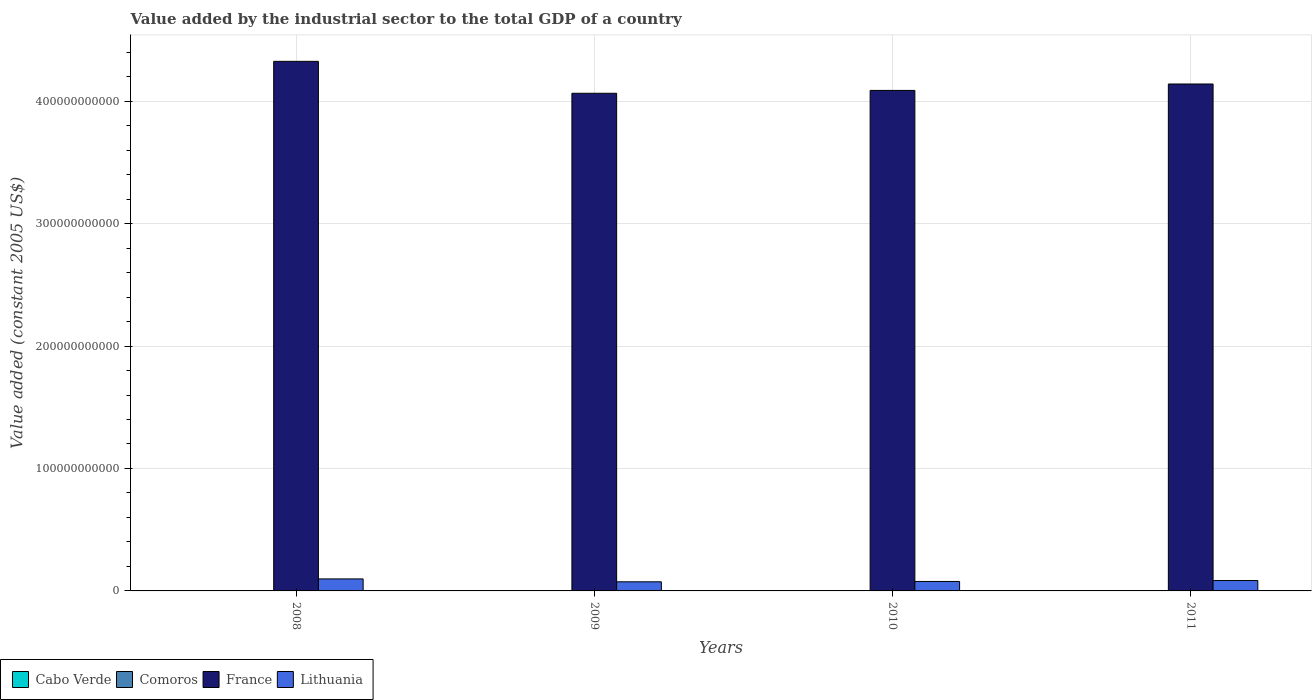How many different coloured bars are there?
Provide a succinct answer. 4. How many groups of bars are there?
Your answer should be compact. 4. How many bars are there on the 2nd tick from the right?
Make the answer very short. 4. In how many cases, is the number of bars for a given year not equal to the number of legend labels?
Give a very brief answer. 0. What is the value added by the industrial sector in Cabo Verde in 2009?
Offer a very short reply. 2.57e+08. Across all years, what is the maximum value added by the industrial sector in Lithuania?
Your answer should be compact. 9.80e+09. Across all years, what is the minimum value added by the industrial sector in Comoros?
Provide a short and direct response. 4.62e+07. In which year was the value added by the industrial sector in Comoros maximum?
Your response must be concise. 2011. What is the total value added by the industrial sector in Comoros in the graph?
Offer a terse response. 2.01e+08. What is the difference between the value added by the industrial sector in Comoros in 2008 and that in 2009?
Your response must be concise. -9.57e+05. What is the difference between the value added by the industrial sector in Cabo Verde in 2008 and the value added by the industrial sector in Lithuania in 2011?
Make the answer very short. -8.21e+09. What is the average value added by the industrial sector in Cabo Verde per year?
Give a very brief answer. 2.57e+08. In the year 2008, what is the difference between the value added by the industrial sector in Comoros and value added by the industrial sector in France?
Keep it short and to the point. -4.32e+11. In how many years, is the value added by the industrial sector in France greater than 260000000000 US$?
Keep it short and to the point. 4. What is the ratio of the value added by the industrial sector in Comoros in 2008 to that in 2010?
Offer a very short reply. 0.87. Is the value added by the industrial sector in France in 2008 less than that in 2011?
Give a very brief answer. No. Is the difference between the value added by the industrial sector in Comoros in 2008 and 2010 greater than the difference between the value added by the industrial sector in France in 2008 and 2010?
Make the answer very short. No. What is the difference between the highest and the second highest value added by the industrial sector in France?
Provide a succinct answer. 1.85e+1. What is the difference between the highest and the lowest value added by the industrial sector in France?
Ensure brevity in your answer.  2.61e+1. In how many years, is the value added by the industrial sector in Comoros greater than the average value added by the industrial sector in Comoros taken over all years?
Ensure brevity in your answer.  2. Is it the case that in every year, the sum of the value added by the industrial sector in Cabo Verde and value added by the industrial sector in Comoros is greater than the sum of value added by the industrial sector in France and value added by the industrial sector in Lithuania?
Make the answer very short. No. What does the 2nd bar from the left in 2009 represents?
Provide a short and direct response. Comoros. How many bars are there?
Your answer should be compact. 16. What is the difference between two consecutive major ticks on the Y-axis?
Your answer should be very brief. 1.00e+11. Are the values on the major ticks of Y-axis written in scientific E-notation?
Ensure brevity in your answer.  No. Does the graph contain grids?
Keep it short and to the point. Yes. Where does the legend appear in the graph?
Your response must be concise. Bottom left. How are the legend labels stacked?
Make the answer very short. Horizontal. What is the title of the graph?
Your answer should be compact. Value added by the industrial sector to the total GDP of a country. Does "Italy" appear as one of the legend labels in the graph?
Keep it short and to the point. No. What is the label or title of the X-axis?
Offer a very short reply. Years. What is the label or title of the Y-axis?
Your answer should be compact. Value added (constant 2005 US$). What is the Value added (constant 2005 US$) in Cabo Verde in 2008?
Ensure brevity in your answer.  2.71e+08. What is the Value added (constant 2005 US$) in Comoros in 2008?
Give a very brief answer. 4.62e+07. What is the Value added (constant 2005 US$) of France in 2008?
Make the answer very short. 4.33e+11. What is the Value added (constant 2005 US$) of Lithuania in 2008?
Provide a succinct answer. 9.80e+09. What is the Value added (constant 2005 US$) in Cabo Verde in 2009?
Your answer should be very brief. 2.57e+08. What is the Value added (constant 2005 US$) in Comoros in 2009?
Keep it short and to the point. 4.71e+07. What is the Value added (constant 2005 US$) in France in 2009?
Provide a succinct answer. 4.06e+11. What is the Value added (constant 2005 US$) in Lithuania in 2009?
Give a very brief answer. 7.44e+09. What is the Value added (constant 2005 US$) of Cabo Verde in 2010?
Give a very brief answer. 2.48e+08. What is the Value added (constant 2005 US$) of Comoros in 2010?
Provide a succinct answer. 5.31e+07. What is the Value added (constant 2005 US$) in France in 2010?
Provide a short and direct response. 4.09e+11. What is the Value added (constant 2005 US$) in Lithuania in 2010?
Your answer should be compact. 7.73e+09. What is the Value added (constant 2005 US$) in Cabo Verde in 2011?
Your answer should be very brief. 2.51e+08. What is the Value added (constant 2005 US$) of Comoros in 2011?
Give a very brief answer. 5.48e+07. What is the Value added (constant 2005 US$) of France in 2011?
Keep it short and to the point. 4.14e+11. What is the Value added (constant 2005 US$) of Lithuania in 2011?
Make the answer very short. 8.48e+09. Across all years, what is the maximum Value added (constant 2005 US$) in Cabo Verde?
Keep it short and to the point. 2.71e+08. Across all years, what is the maximum Value added (constant 2005 US$) of Comoros?
Give a very brief answer. 5.48e+07. Across all years, what is the maximum Value added (constant 2005 US$) of France?
Your answer should be compact. 4.33e+11. Across all years, what is the maximum Value added (constant 2005 US$) in Lithuania?
Offer a very short reply. 9.80e+09. Across all years, what is the minimum Value added (constant 2005 US$) in Cabo Verde?
Provide a succinct answer. 2.48e+08. Across all years, what is the minimum Value added (constant 2005 US$) of Comoros?
Provide a short and direct response. 4.62e+07. Across all years, what is the minimum Value added (constant 2005 US$) in France?
Make the answer very short. 4.06e+11. Across all years, what is the minimum Value added (constant 2005 US$) of Lithuania?
Your answer should be compact. 7.44e+09. What is the total Value added (constant 2005 US$) of Cabo Verde in the graph?
Your answer should be compact. 1.03e+09. What is the total Value added (constant 2005 US$) in Comoros in the graph?
Ensure brevity in your answer.  2.01e+08. What is the total Value added (constant 2005 US$) in France in the graph?
Your answer should be compact. 1.66e+12. What is the total Value added (constant 2005 US$) of Lithuania in the graph?
Make the answer very short. 3.35e+1. What is the difference between the Value added (constant 2005 US$) of Cabo Verde in 2008 and that in 2009?
Provide a short and direct response. 1.46e+07. What is the difference between the Value added (constant 2005 US$) of Comoros in 2008 and that in 2009?
Provide a succinct answer. -9.57e+05. What is the difference between the Value added (constant 2005 US$) in France in 2008 and that in 2009?
Provide a succinct answer. 2.61e+1. What is the difference between the Value added (constant 2005 US$) of Lithuania in 2008 and that in 2009?
Offer a terse response. 2.36e+09. What is the difference between the Value added (constant 2005 US$) of Cabo Verde in 2008 and that in 2010?
Offer a terse response. 2.35e+07. What is the difference between the Value added (constant 2005 US$) in Comoros in 2008 and that in 2010?
Your answer should be compact. -6.95e+06. What is the difference between the Value added (constant 2005 US$) in France in 2008 and that in 2010?
Ensure brevity in your answer.  2.37e+1. What is the difference between the Value added (constant 2005 US$) in Lithuania in 2008 and that in 2010?
Offer a terse response. 2.07e+09. What is the difference between the Value added (constant 2005 US$) of Cabo Verde in 2008 and that in 2011?
Your answer should be compact. 2.03e+07. What is the difference between the Value added (constant 2005 US$) in Comoros in 2008 and that in 2011?
Provide a succinct answer. -8.59e+06. What is the difference between the Value added (constant 2005 US$) of France in 2008 and that in 2011?
Provide a succinct answer. 1.85e+1. What is the difference between the Value added (constant 2005 US$) in Lithuania in 2008 and that in 2011?
Your response must be concise. 1.32e+09. What is the difference between the Value added (constant 2005 US$) of Cabo Verde in 2009 and that in 2010?
Your answer should be compact. 8.92e+06. What is the difference between the Value added (constant 2005 US$) of Comoros in 2009 and that in 2010?
Offer a very short reply. -5.99e+06. What is the difference between the Value added (constant 2005 US$) of France in 2009 and that in 2010?
Provide a succinct answer. -2.34e+09. What is the difference between the Value added (constant 2005 US$) in Lithuania in 2009 and that in 2010?
Your response must be concise. -2.85e+08. What is the difference between the Value added (constant 2005 US$) of Cabo Verde in 2009 and that in 2011?
Your answer should be very brief. 5.76e+06. What is the difference between the Value added (constant 2005 US$) in Comoros in 2009 and that in 2011?
Offer a terse response. -7.64e+06. What is the difference between the Value added (constant 2005 US$) in France in 2009 and that in 2011?
Offer a very short reply. -7.58e+09. What is the difference between the Value added (constant 2005 US$) in Lithuania in 2009 and that in 2011?
Give a very brief answer. -1.04e+09. What is the difference between the Value added (constant 2005 US$) of Cabo Verde in 2010 and that in 2011?
Keep it short and to the point. -3.16e+06. What is the difference between the Value added (constant 2005 US$) in Comoros in 2010 and that in 2011?
Your answer should be compact. -1.64e+06. What is the difference between the Value added (constant 2005 US$) in France in 2010 and that in 2011?
Provide a succinct answer. -5.24e+09. What is the difference between the Value added (constant 2005 US$) of Lithuania in 2010 and that in 2011?
Offer a very short reply. -7.52e+08. What is the difference between the Value added (constant 2005 US$) of Cabo Verde in 2008 and the Value added (constant 2005 US$) of Comoros in 2009?
Provide a succinct answer. 2.24e+08. What is the difference between the Value added (constant 2005 US$) of Cabo Verde in 2008 and the Value added (constant 2005 US$) of France in 2009?
Your response must be concise. -4.06e+11. What is the difference between the Value added (constant 2005 US$) of Cabo Verde in 2008 and the Value added (constant 2005 US$) of Lithuania in 2009?
Your answer should be very brief. -7.17e+09. What is the difference between the Value added (constant 2005 US$) of Comoros in 2008 and the Value added (constant 2005 US$) of France in 2009?
Make the answer very short. -4.06e+11. What is the difference between the Value added (constant 2005 US$) in Comoros in 2008 and the Value added (constant 2005 US$) in Lithuania in 2009?
Offer a terse response. -7.40e+09. What is the difference between the Value added (constant 2005 US$) in France in 2008 and the Value added (constant 2005 US$) in Lithuania in 2009?
Keep it short and to the point. 4.25e+11. What is the difference between the Value added (constant 2005 US$) of Cabo Verde in 2008 and the Value added (constant 2005 US$) of Comoros in 2010?
Ensure brevity in your answer.  2.18e+08. What is the difference between the Value added (constant 2005 US$) of Cabo Verde in 2008 and the Value added (constant 2005 US$) of France in 2010?
Offer a very short reply. -4.09e+11. What is the difference between the Value added (constant 2005 US$) in Cabo Verde in 2008 and the Value added (constant 2005 US$) in Lithuania in 2010?
Keep it short and to the point. -7.46e+09. What is the difference between the Value added (constant 2005 US$) in Comoros in 2008 and the Value added (constant 2005 US$) in France in 2010?
Offer a terse response. -4.09e+11. What is the difference between the Value added (constant 2005 US$) in Comoros in 2008 and the Value added (constant 2005 US$) in Lithuania in 2010?
Make the answer very short. -7.68e+09. What is the difference between the Value added (constant 2005 US$) in France in 2008 and the Value added (constant 2005 US$) in Lithuania in 2010?
Your response must be concise. 4.25e+11. What is the difference between the Value added (constant 2005 US$) in Cabo Verde in 2008 and the Value added (constant 2005 US$) in Comoros in 2011?
Your response must be concise. 2.17e+08. What is the difference between the Value added (constant 2005 US$) in Cabo Verde in 2008 and the Value added (constant 2005 US$) in France in 2011?
Provide a succinct answer. -4.14e+11. What is the difference between the Value added (constant 2005 US$) of Cabo Verde in 2008 and the Value added (constant 2005 US$) of Lithuania in 2011?
Keep it short and to the point. -8.21e+09. What is the difference between the Value added (constant 2005 US$) of Comoros in 2008 and the Value added (constant 2005 US$) of France in 2011?
Give a very brief answer. -4.14e+11. What is the difference between the Value added (constant 2005 US$) in Comoros in 2008 and the Value added (constant 2005 US$) in Lithuania in 2011?
Offer a very short reply. -8.43e+09. What is the difference between the Value added (constant 2005 US$) in France in 2008 and the Value added (constant 2005 US$) in Lithuania in 2011?
Your response must be concise. 4.24e+11. What is the difference between the Value added (constant 2005 US$) of Cabo Verde in 2009 and the Value added (constant 2005 US$) of Comoros in 2010?
Keep it short and to the point. 2.04e+08. What is the difference between the Value added (constant 2005 US$) in Cabo Verde in 2009 and the Value added (constant 2005 US$) in France in 2010?
Your answer should be compact. -4.09e+11. What is the difference between the Value added (constant 2005 US$) in Cabo Verde in 2009 and the Value added (constant 2005 US$) in Lithuania in 2010?
Your response must be concise. -7.47e+09. What is the difference between the Value added (constant 2005 US$) of Comoros in 2009 and the Value added (constant 2005 US$) of France in 2010?
Make the answer very short. -4.09e+11. What is the difference between the Value added (constant 2005 US$) of Comoros in 2009 and the Value added (constant 2005 US$) of Lithuania in 2010?
Make the answer very short. -7.68e+09. What is the difference between the Value added (constant 2005 US$) in France in 2009 and the Value added (constant 2005 US$) in Lithuania in 2010?
Ensure brevity in your answer.  3.99e+11. What is the difference between the Value added (constant 2005 US$) in Cabo Verde in 2009 and the Value added (constant 2005 US$) in Comoros in 2011?
Keep it short and to the point. 2.02e+08. What is the difference between the Value added (constant 2005 US$) in Cabo Verde in 2009 and the Value added (constant 2005 US$) in France in 2011?
Give a very brief answer. -4.14e+11. What is the difference between the Value added (constant 2005 US$) in Cabo Verde in 2009 and the Value added (constant 2005 US$) in Lithuania in 2011?
Your response must be concise. -8.22e+09. What is the difference between the Value added (constant 2005 US$) in Comoros in 2009 and the Value added (constant 2005 US$) in France in 2011?
Your response must be concise. -4.14e+11. What is the difference between the Value added (constant 2005 US$) of Comoros in 2009 and the Value added (constant 2005 US$) of Lithuania in 2011?
Your response must be concise. -8.43e+09. What is the difference between the Value added (constant 2005 US$) of France in 2009 and the Value added (constant 2005 US$) of Lithuania in 2011?
Offer a terse response. 3.98e+11. What is the difference between the Value added (constant 2005 US$) of Cabo Verde in 2010 and the Value added (constant 2005 US$) of Comoros in 2011?
Give a very brief answer. 1.93e+08. What is the difference between the Value added (constant 2005 US$) of Cabo Verde in 2010 and the Value added (constant 2005 US$) of France in 2011?
Keep it short and to the point. -4.14e+11. What is the difference between the Value added (constant 2005 US$) of Cabo Verde in 2010 and the Value added (constant 2005 US$) of Lithuania in 2011?
Your answer should be very brief. -8.23e+09. What is the difference between the Value added (constant 2005 US$) in Comoros in 2010 and the Value added (constant 2005 US$) in France in 2011?
Your answer should be compact. -4.14e+11. What is the difference between the Value added (constant 2005 US$) of Comoros in 2010 and the Value added (constant 2005 US$) of Lithuania in 2011?
Make the answer very short. -8.43e+09. What is the difference between the Value added (constant 2005 US$) of France in 2010 and the Value added (constant 2005 US$) of Lithuania in 2011?
Give a very brief answer. 4.00e+11. What is the average Value added (constant 2005 US$) of Cabo Verde per year?
Ensure brevity in your answer.  2.57e+08. What is the average Value added (constant 2005 US$) of Comoros per year?
Your answer should be compact. 5.03e+07. What is the average Value added (constant 2005 US$) in France per year?
Your answer should be compact. 4.15e+11. What is the average Value added (constant 2005 US$) of Lithuania per year?
Offer a terse response. 8.36e+09. In the year 2008, what is the difference between the Value added (constant 2005 US$) of Cabo Verde and Value added (constant 2005 US$) of Comoros?
Make the answer very short. 2.25e+08. In the year 2008, what is the difference between the Value added (constant 2005 US$) of Cabo Verde and Value added (constant 2005 US$) of France?
Your answer should be compact. -4.32e+11. In the year 2008, what is the difference between the Value added (constant 2005 US$) in Cabo Verde and Value added (constant 2005 US$) in Lithuania?
Make the answer very short. -9.53e+09. In the year 2008, what is the difference between the Value added (constant 2005 US$) in Comoros and Value added (constant 2005 US$) in France?
Your answer should be very brief. -4.32e+11. In the year 2008, what is the difference between the Value added (constant 2005 US$) of Comoros and Value added (constant 2005 US$) of Lithuania?
Your response must be concise. -9.76e+09. In the year 2008, what is the difference between the Value added (constant 2005 US$) of France and Value added (constant 2005 US$) of Lithuania?
Your answer should be compact. 4.23e+11. In the year 2009, what is the difference between the Value added (constant 2005 US$) of Cabo Verde and Value added (constant 2005 US$) of Comoros?
Your answer should be compact. 2.10e+08. In the year 2009, what is the difference between the Value added (constant 2005 US$) of Cabo Verde and Value added (constant 2005 US$) of France?
Your answer should be compact. -4.06e+11. In the year 2009, what is the difference between the Value added (constant 2005 US$) of Cabo Verde and Value added (constant 2005 US$) of Lithuania?
Your response must be concise. -7.19e+09. In the year 2009, what is the difference between the Value added (constant 2005 US$) of Comoros and Value added (constant 2005 US$) of France?
Your response must be concise. -4.06e+11. In the year 2009, what is the difference between the Value added (constant 2005 US$) of Comoros and Value added (constant 2005 US$) of Lithuania?
Your answer should be very brief. -7.40e+09. In the year 2009, what is the difference between the Value added (constant 2005 US$) in France and Value added (constant 2005 US$) in Lithuania?
Your answer should be compact. 3.99e+11. In the year 2010, what is the difference between the Value added (constant 2005 US$) in Cabo Verde and Value added (constant 2005 US$) in Comoros?
Provide a short and direct response. 1.95e+08. In the year 2010, what is the difference between the Value added (constant 2005 US$) in Cabo Verde and Value added (constant 2005 US$) in France?
Give a very brief answer. -4.09e+11. In the year 2010, what is the difference between the Value added (constant 2005 US$) of Cabo Verde and Value added (constant 2005 US$) of Lithuania?
Keep it short and to the point. -7.48e+09. In the year 2010, what is the difference between the Value added (constant 2005 US$) in Comoros and Value added (constant 2005 US$) in France?
Your answer should be compact. -4.09e+11. In the year 2010, what is the difference between the Value added (constant 2005 US$) in Comoros and Value added (constant 2005 US$) in Lithuania?
Offer a very short reply. -7.68e+09. In the year 2010, what is the difference between the Value added (constant 2005 US$) of France and Value added (constant 2005 US$) of Lithuania?
Your answer should be very brief. 4.01e+11. In the year 2011, what is the difference between the Value added (constant 2005 US$) in Cabo Verde and Value added (constant 2005 US$) in Comoros?
Provide a succinct answer. 1.96e+08. In the year 2011, what is the difference between the Value added (constant 2005 US$) in Cabo Verde and Value added (constant 2005 US$) in France?
Offer a very short reply. -4.14e+11. In the year 2011, what is the difference between the Value added (constant 2005 US$) in Cabo Verde and Value added (constant 2005 US$) in Lithuania?
Provide a succinct answer. -8.23e+09. In the year 2011, what is the difference between the Value added (constant 2005 US$) in Comoros and Value added (constant 2005 US$) in France?
Your response must be concise. -4.14e+11. In the year 2011, what is the difference between the Value added (constant 2005 US$) in Comoros and Value added (constant 2005 US$) in Lithuania?
Offer a very short reply. -8.43e+09. In the year 2011, what is the difference between the Value added (constant 2005 US$) of France and Value added (constant 2005 US$) of Lithuania?
Your answer should be compact. 4.06e+11. What is the ratio of the Value added (constant 2005 US$) in Cabo Verde in 2008 to that in 2009?
Make the answer very short. 1.06. What is the ratio of the Value added (constant 2005 US$) in Comoros in 2008 to that in 2009?
Keep it short and to the point. 0.98. What is the ratio of the Value added (constant 2005 US$) in France in 2008 to that in 2009?
Offer a very short reply. 1.06. What is the ratio of the Value added (constant 2005 US$) in Lithuania in 2008 to that in 2009?
Provide a succinct answer. 1.32. What is the ratio of the Value added (constant 2005 US$) of Cabo Verde in 2008 to that in 2010?
Keep it short and to the point. 1.09. What is the ratio of the Value added (constant 2005 US$) in Comoros in 2008 to that in 2010?
Offer a terse response. 0.87. What is the ratio of the Value added (constant 2005 US$) in France in 2008 to that in 2010?
Make the answer very short. 1.06. What is the ratio of the Value added (constant 2005 US$) in Lithuania in 2008 to that in 2010?
Provide a short and direct response. 1.27. What is the ratio of the Value added (constant 2005 US$) in Cabo Verde in 2008 to that in 2011?
Your response must be concise. 1.08. What is the ratio of the Value added (constant 2005 US$) of Comoros in 2008 to that in 2011?
Ensure brevity in your answer.  0.84. What is the ratio of the Value added (constant 2005 US$) in France in 2008 to that in 2011?
Offer a very short reply. 1.04. What is the ratio of the Value added (constant 2005 US$) in Lithuania in 2008 to that in 2011?
Offer a very short reply. 1.16. What is the ratio of the Value added (constant 2005 US$) in Cabo Verde in 2009 to that in 2010?
Make the answer very short. 1.04. What is the ratio of the Value added (constant 2005 US$) in Comoros in 2009 to that in 2010?
Provide a short and direct response. 0.89. What is the ratio of the Value added (constant 2005 US$) of France in 2009 to that in 2010?
Provide a succinct answer. 0.99. What is the ratio of the Value added (constant 2005 US$) of Lithuania in 2009 to that in 2010?
Keep it short and to the point. 0.96. What is the ratio of the Value added (constant 2005 US$) in Cabo Verde in 2009 to that in 2011?
Keep it short and to the point. 1.02. What is the ratio of the Value added (constant 2005 US$) of Comoros in 2009 to that in 2011?
Ensure brevity in your answer.  0.86. What is the ratio of the Value added (constant 2005 US$) of France in 2009 to that in 2011?
Your response must be concise. 0.98. What is the ratio of the Value added (constant 2005 US$) in Lithuania in 2009 to that in 2011?
Your response must be concise. 0.88. What is the ratio of the Value added (constant 2005 US$) of Cabo Verde in 2010 to that in 2011?
Your answer should be very brief. 0.99. What is the ratio of the Value added (constant 2005 US$) in France in 2010 to that in 2011?
Provide a succinct answer. 0.99. What is the ratio of the Value added (constant 2005 US$) in Lithuania in 2010 to that in 2011?
Your answer should be compact. 0.91. What is the difference between the highest and the second highest Value added (constant 2005 US$) of Cabo Verde?
Your answer should be compact. 1.46e+07. What is the difference between the highest and the second highest Value added (constant 2005 US$) of Comoros?
Ensure brevity in your answer.  1.64e+06. What is the difference between the highest and the second highest Value added (constant 2005 US$) of France?
Offer a terse response. 1.85e+1. What is the difference between the highest and the second highest Value added (constant 2005 US$) of Lithuania?
Your answer should be compact. 1.32e+09. What is the difference between the highest and the lowest Value added (constant 2005 US$) of Cabo Verde?
Your response must be concise. 2.35e+07. What is the difference between the highest and the lowest Value added (constant 2005 US$) in Comoros?
Provide a short and direct response. 8.59e+06. What is the difference between the highest and the lowest Value added (constant 2005 US$) of France?
Your response must be concise. 2.61e+1. What is the difference between the highest and the lowest Value added (constant 2005 US$) of Lithuania?
Provide a short and direct response. 2.36e+09. 